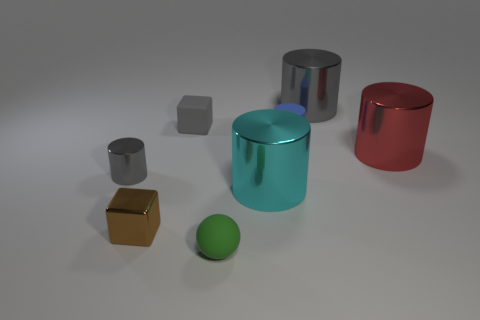Subtract all small gray shiny cylinders. How many cylinders are left? 4 Add 1 small yellow cylinders. How many objects exist? 9 Subtract all cyan cylinders. How many cylinders are left? 4 Subtract all green cylinders. Subtract all purple balls. How many cylinders are left? 5 Subtract all blue cylinders. How many brown cubes are left? 1 Subtract all big green shiny things. Subtract all big gray shiny objects. How many objects are left? 7 Add 7 blue cylinders. How many blue cylinders are left? 8 Add 5 tiny metal blocks. How many tiny metal blocks exist? 6 Subtract 0 yellow cylinders. How many objects are left? 8 Subtract all blocks. How many objects are left? 6 